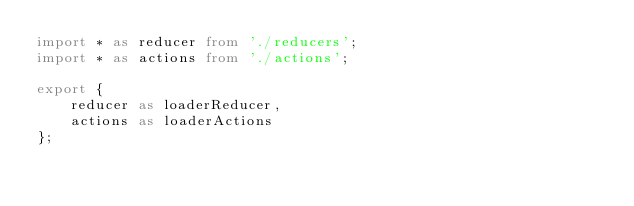Convert code to text. <code><loc_0><loc_0><loc_500><loc_500><_TypeScript_>import * as reducer from './reducers';
import * as actions from './actions';

export {
    reducer as loaderReducer,
    actions as loaderActions
};
</code> 